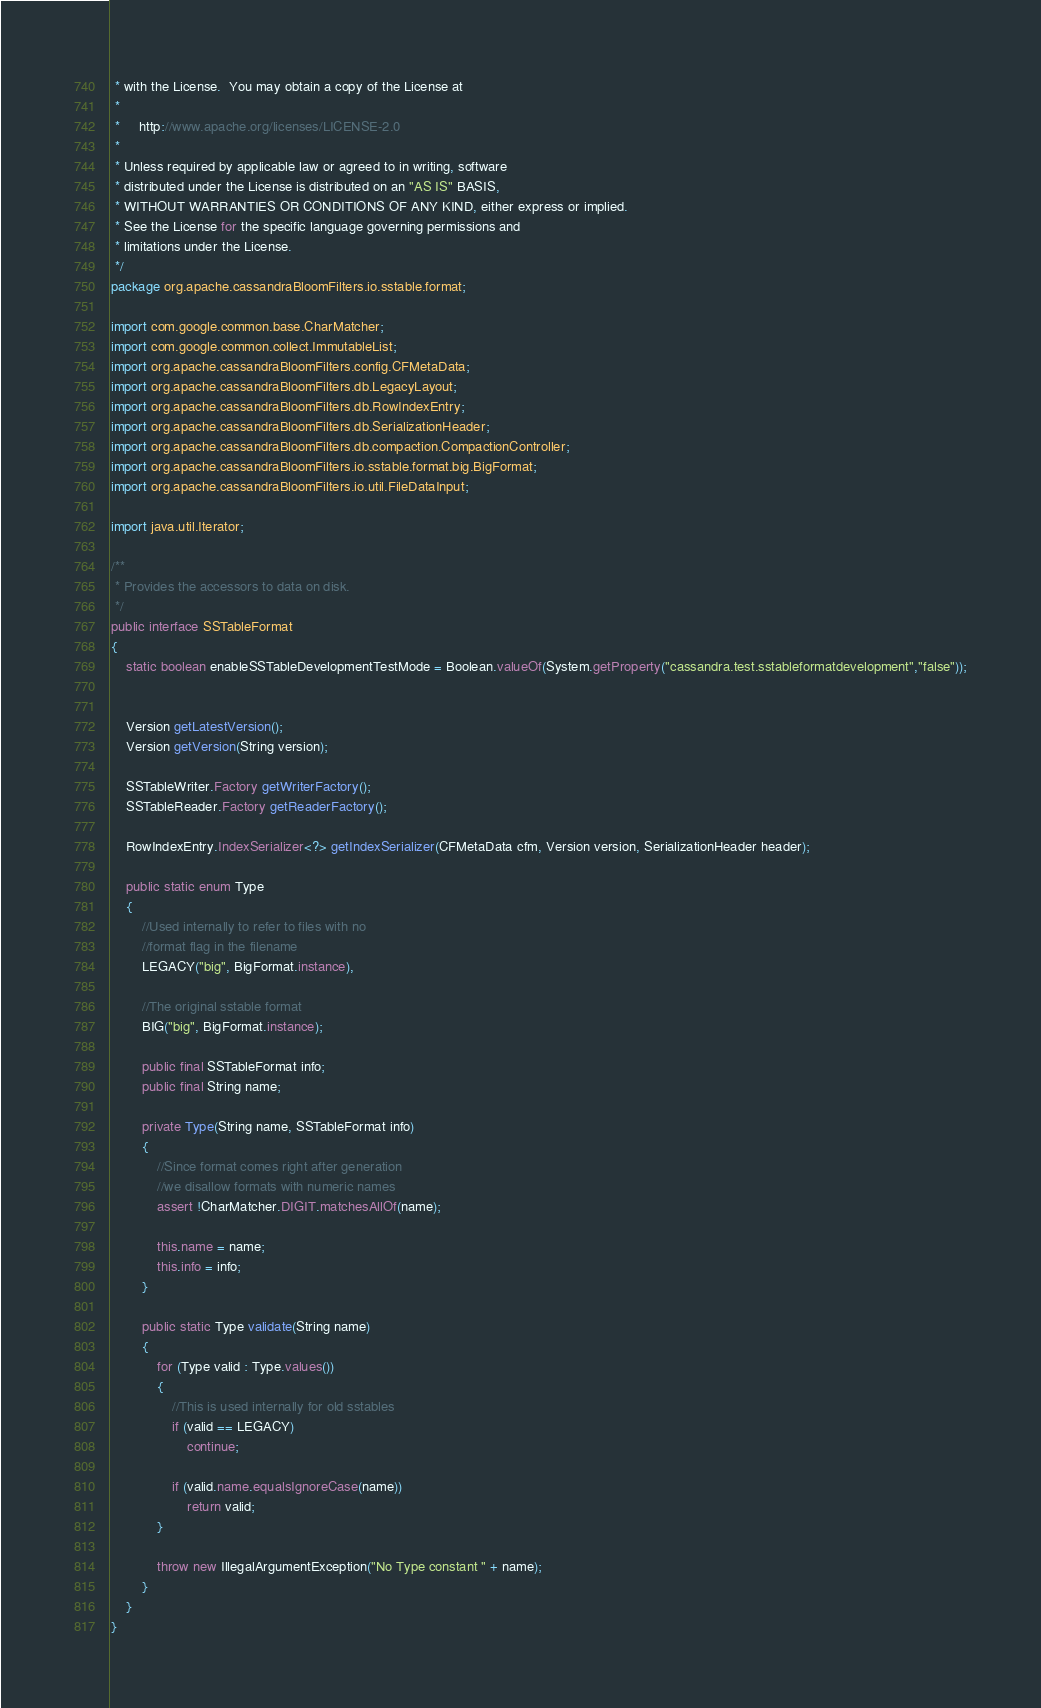Convert code to text. <code><loc_0><loc_0><loc_500><loc_500><_Java_> * with the License.  You may obtain a copy of the License at
 *
 *     http://www.apache.org/licenses/LICENSE-2.0
 *
 * Unless required by applicable law or agreed to in writing, software
 * distributed under the License is distributed on an "AS IS" BASIS,
 * WITHOUT WARRANTIES OR CONDITIONS OF ANY KIND, either express or implied.
 * See the License for the specific language governing permissions and
 * limitations under the License.
 */
package org.apache.cassandraBloomFilters.io.sstable.format;

import com.google.common.base.CharMatcher;
import com.google.common.collect.ImmutableList;
import org.apache.cassandraBloomFilters.config.CFMetaData;
import org.apache.cassandraBloomFilters.db.LegacyLayout;
import org.apache.cassandraBloomFilters.db.RowIndexEntry;
import org.apache.cassandraBloomFilters.db.SerializationHeader;
import org.apache.cassandraBloomFilters.db.compaction.CompactionController;
import org.apache.cassandraBloomFilters.io.sstable.format.big.BigFormat;
import org.apache.cassandraBloomFilters.io.util.FileDataInput;

import java.util.Iterator;

/**
 * Provides the accessors to data on disk.
 */
public interface SSTableFormat
{
    static boolean enableSSTableDevelopmentTestMode = Boolean.valueOf(System.getProperty("cassandra.test.sstableformatdevelopment","false"));


    Version getLatestVersion();
    Version getVersion(String version);

    SSTableWriter.Factory getWriterFactory();
    SSTableReader.Factory getReaderFactory();

    RowIndexEntry.IndexSerializer<?> getIndexSerializer(CFMetaData cfm, Version version, SerializationHeader header);

    public static enum Type
    {
        //Used internally to refer to files with no
        //format flag in the filename
        LEGACY("big", BigFormat.instance),

        //The original sstable format
        BIG("big", BigFormat.instance);

        public final SSTableFormat info;
        public final String name;

        private Type(String name, SSTableFormat info)
        {
            //Since format comes right after generation
            //we disallow formats with numeric names
            assert !CharMatcher.DIGIT.matchesAllOf(name);

            this.name = name;
            this.info = info;
        }

        public static Type validate(String name)
        {
            for (Type valid : Type.values())
            {
                //This is used internally for old sstables
                if (valid == LEGACY)
                    continue;

                if (valid.name.equalsIgnoreCase(name))
                    return valid;
            }

            throw new IllegalArgumentException("No Type constant " + name);
        }
    }
}
</code> 